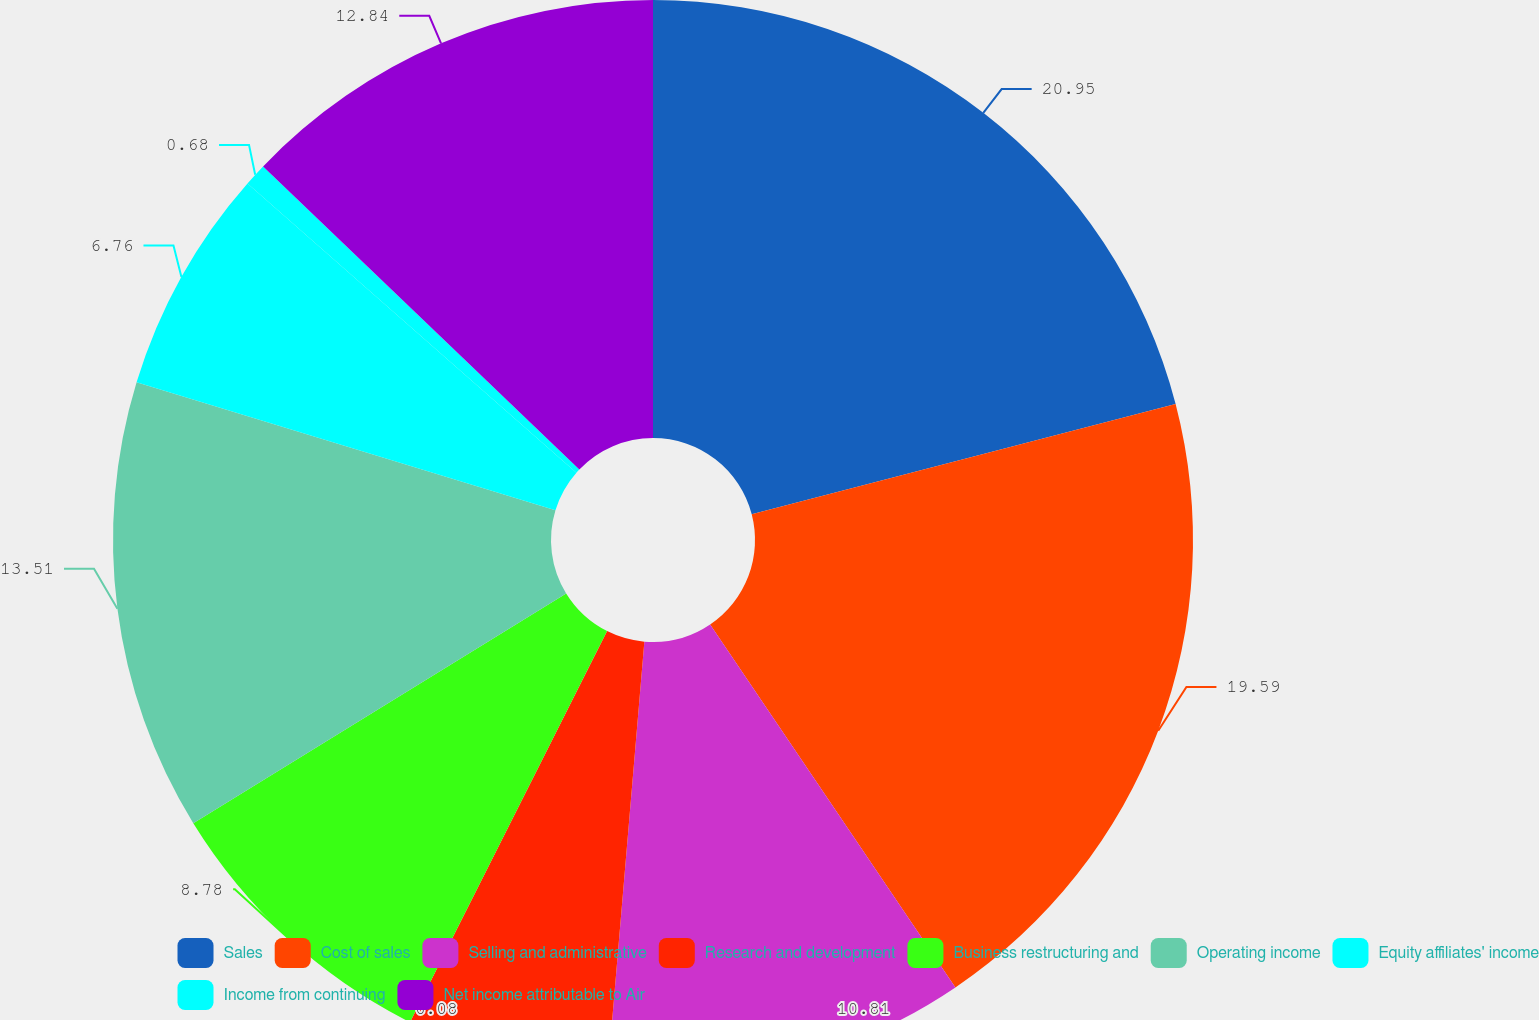Convert chart. <chart><loc_0><loc_0><loc_500><loc_500><pie_chart><fcel>Sales<fcel>Cost of sales<fcel>Selling and administrative<fcel>Research and development<fcel>Business restructuring and<fcel>Operating income<fcel>Equity affiliates' income<fcel>Income from continuing<fcel>Net income attributable to Air<nl><fcel>20.95%<fcel>19.59%<fcel>10.81%<fcel>6.08%<fcel>8.78%<fcel>13.51%<fcel>6.76%<fcel>0.68%<fcel>12.84%<nl></chart> 